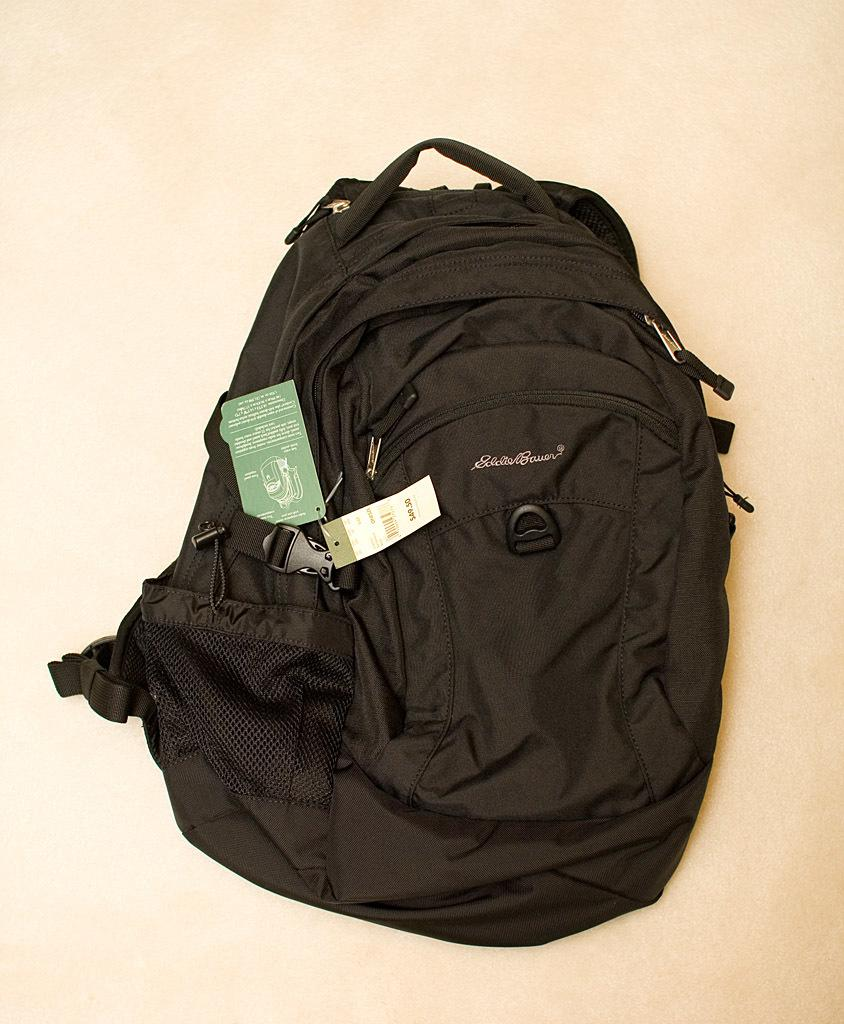What object can be seen in the image? There is a bag in the image. What is the color of the bag? The bag is black in color. What type of juice is being poured out of the bag in the image? There is no juice or any liquid being poured out of the bag in the image; it is a solid object. 